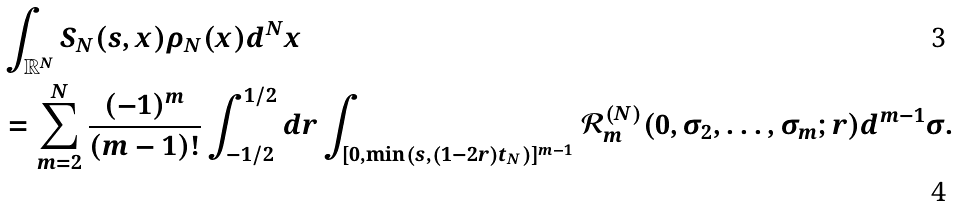Convert formula to latex. <formula><loc_0><loc_0><loc_500><loc_500>& \int _ { \mathbb { R } ^ { N } } S _ { N } ( s , x ) \rho _ { N } ( x ) d ^ { N } x \\ & = \sum _ { m = 2 } ^ { N } \frac { ( - 1 ) ^ { m } } { ( m - 1 ) ! } \int _ { - 1 / 2 } ^ { 1 / 2 } d r \int _ { [ 0 , \min ( s , ( 1 - 2 r ) t _ { N } ) ] ^ { m - 1 } } \mathcal { R } _ { m } ^ { ( N ) } ( 0 , \sigma _ { 2 } , \dots , \sigma _ { m } ; r ) d ^ { m - 1 } \sigma .</formula> 